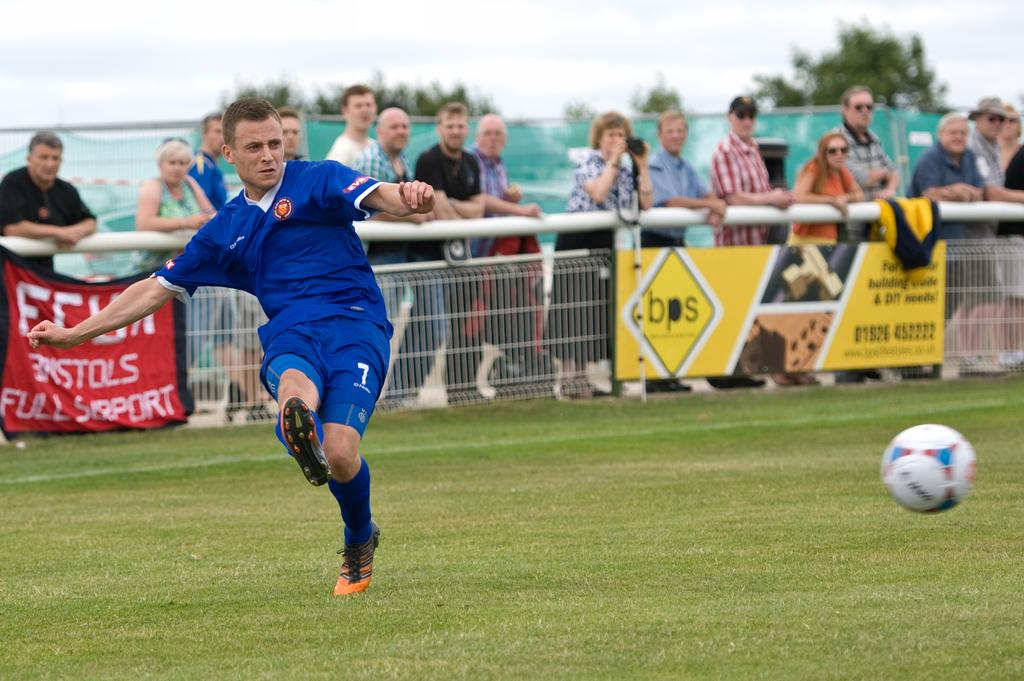<image>
Offer a succinct explanation of the picture presented. A man kicks a football in front of a banner advert for bps 